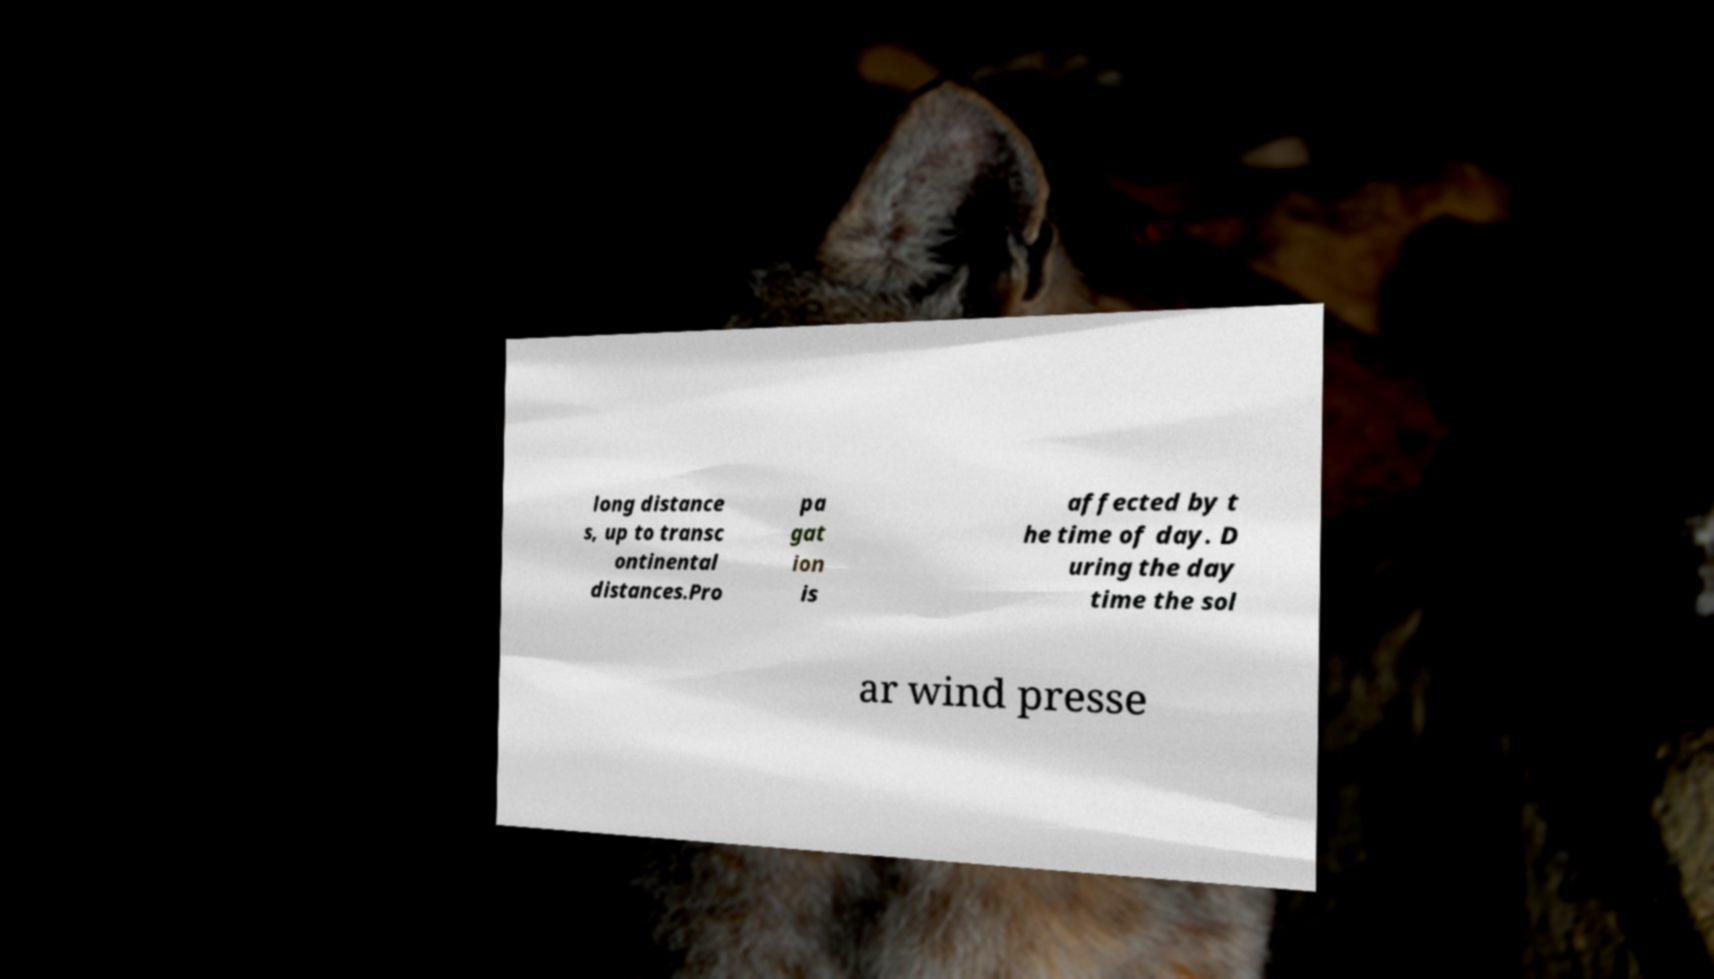I need the written content from this picture converted into text. Can you do that? long distance s, up to transc ontinental distances.Pro pa gat ion is affected by t he time of day. D uring the day time the sol ar wind presse 